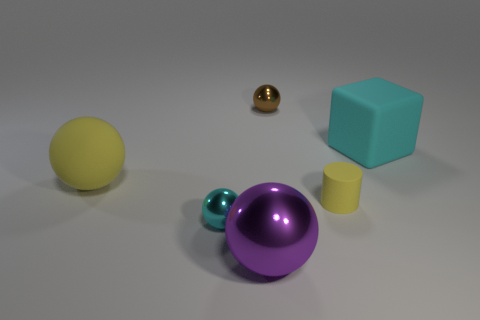Subtract 1 balls. How many balls are left? 3 Add 3 purple things. How many objects exist? 9 Subtract all balls. How many objects are left? 2 Subtract all purple cubes. Subtract all large cyan cubes. How many objects are left? 5 Add 5 purple spheres. How many purple spheres are left? 6 Add 4 yellow matte cylinders. How many yellow matte cylinders exist? 5 Subtract 1 brown balls. How many objects are left? 5 